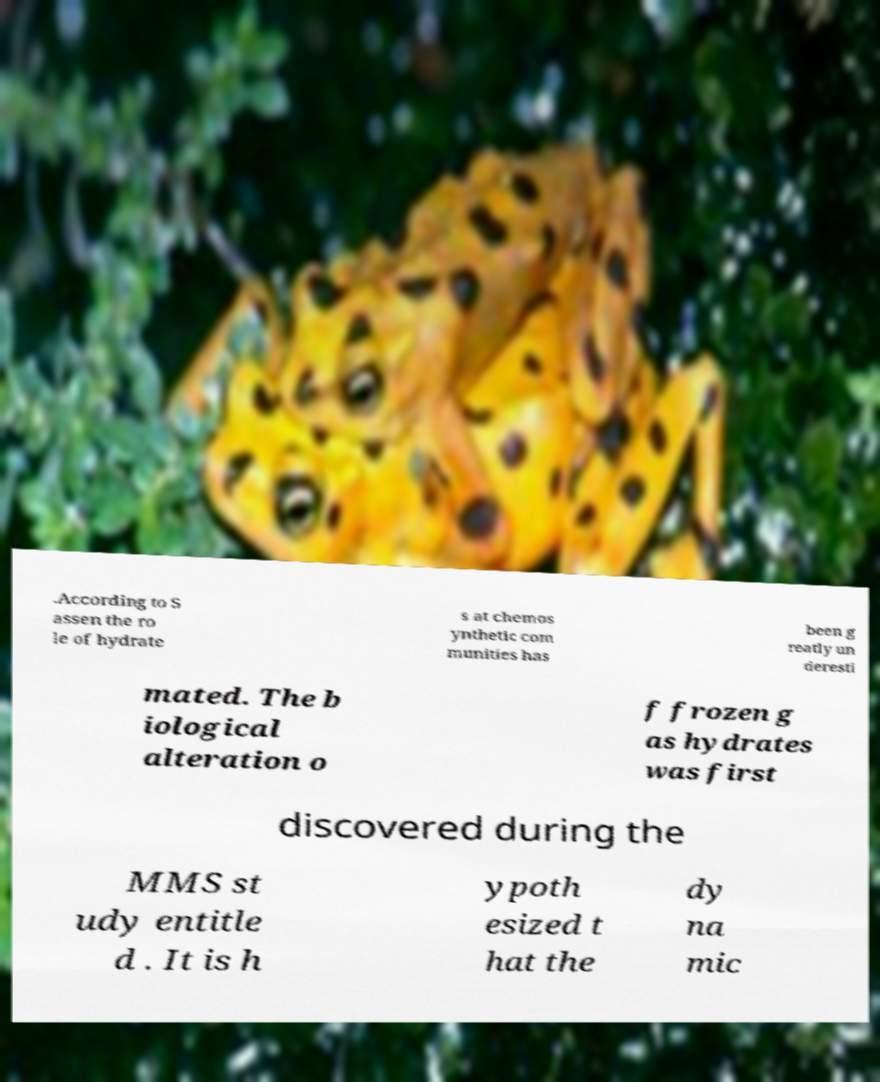I need the written content from this picture converted into text. Can you do that? .According to S assen the ro le of hydrate s at chemos ynthetic com munities has been g reatly un deresti mated. The b iological alteration o f frozen g as hydrates was first discovered during the MMS st udy entitle d . It is h ypoth esized t hat the dy na mic 